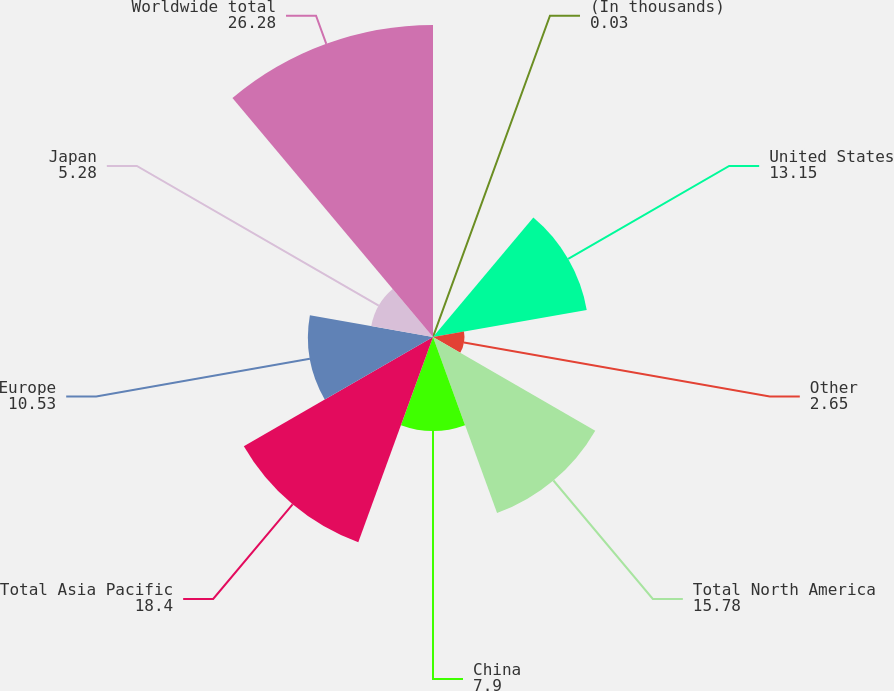Convert chart to OTSL. <chart><loc_0><loc_0><loc_500><loc_500><pie_chart><fcel>(In thousands)<fcel>United States<fcel>Other<fcel>Total North America<fcel>China<fcel>Total Asia Pacific<fcel>Europe<fcel>Japan<fcel>Worldwide total<nl><fcel>0.03%<fcel>13.15%<fcel>2.65%<fcel>15.78%<fcel>7.9%<fcel>18.4%<fcel>10.53%<fcel>5.28%<fcel>26.28%<nl></chart> 